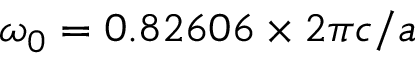Convert formula to latex. <formula><loc_0><loc_0><loc_500><loc_500>\omega _ { 0 } = 0 . 8 2 6 0 6 \times 2 \pi c / a</formula> 